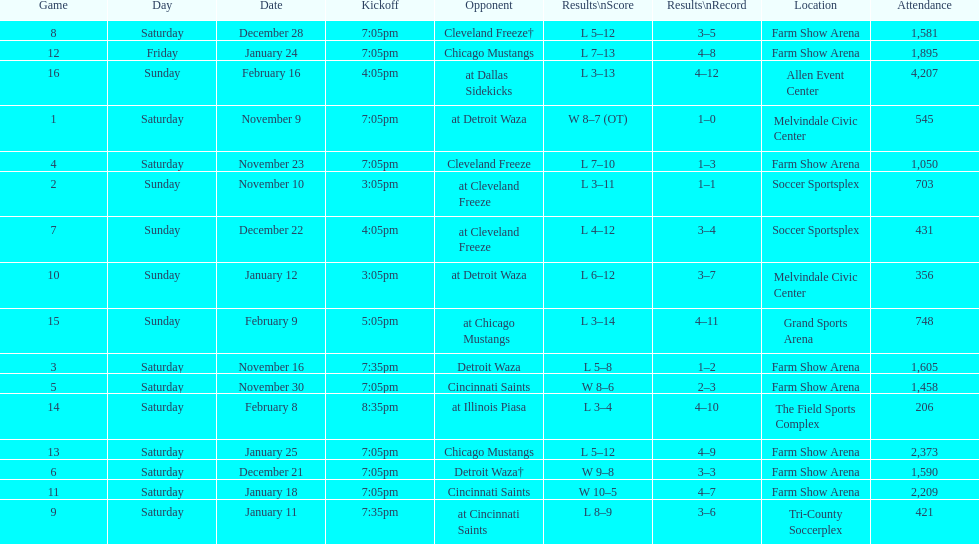In how many occasions did the team play at home yet failed to win? 5. 